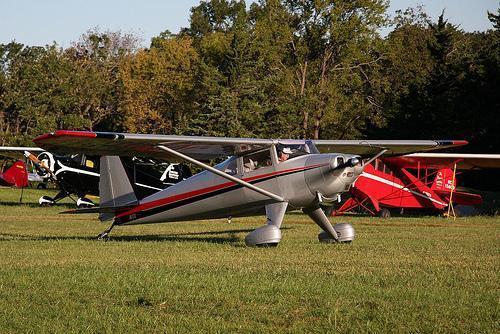How many planes are there?
Give a very brief answer. 3. 